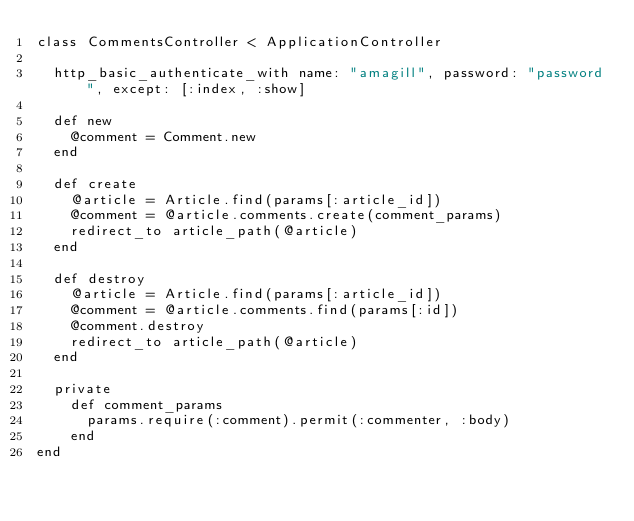<code> <loc_0><loc_0><loc_500><loc_500><_Ruby_>class CommentsController < ApplicationController

	http_basic_authenticate_with name: "amagill", password: "password", except: [:index, :show]

	def new
		@comment = Comment.new
	end

	def create
		@article = Article.find(params[:article_id])
		@comment = @article.comments.create(comment_params)
		redirect_to article_path(@article)
	end

	def destroy
		@article = Article.find(params[:article_id])
		@comment = @article.comments.find(params[:id])
		@comment.destroy
		redirect_to article_path(@article)
	end

	private
		def comment_params
		  params.require(:comment).permit(:commenter, :body)
		end
end</code> 